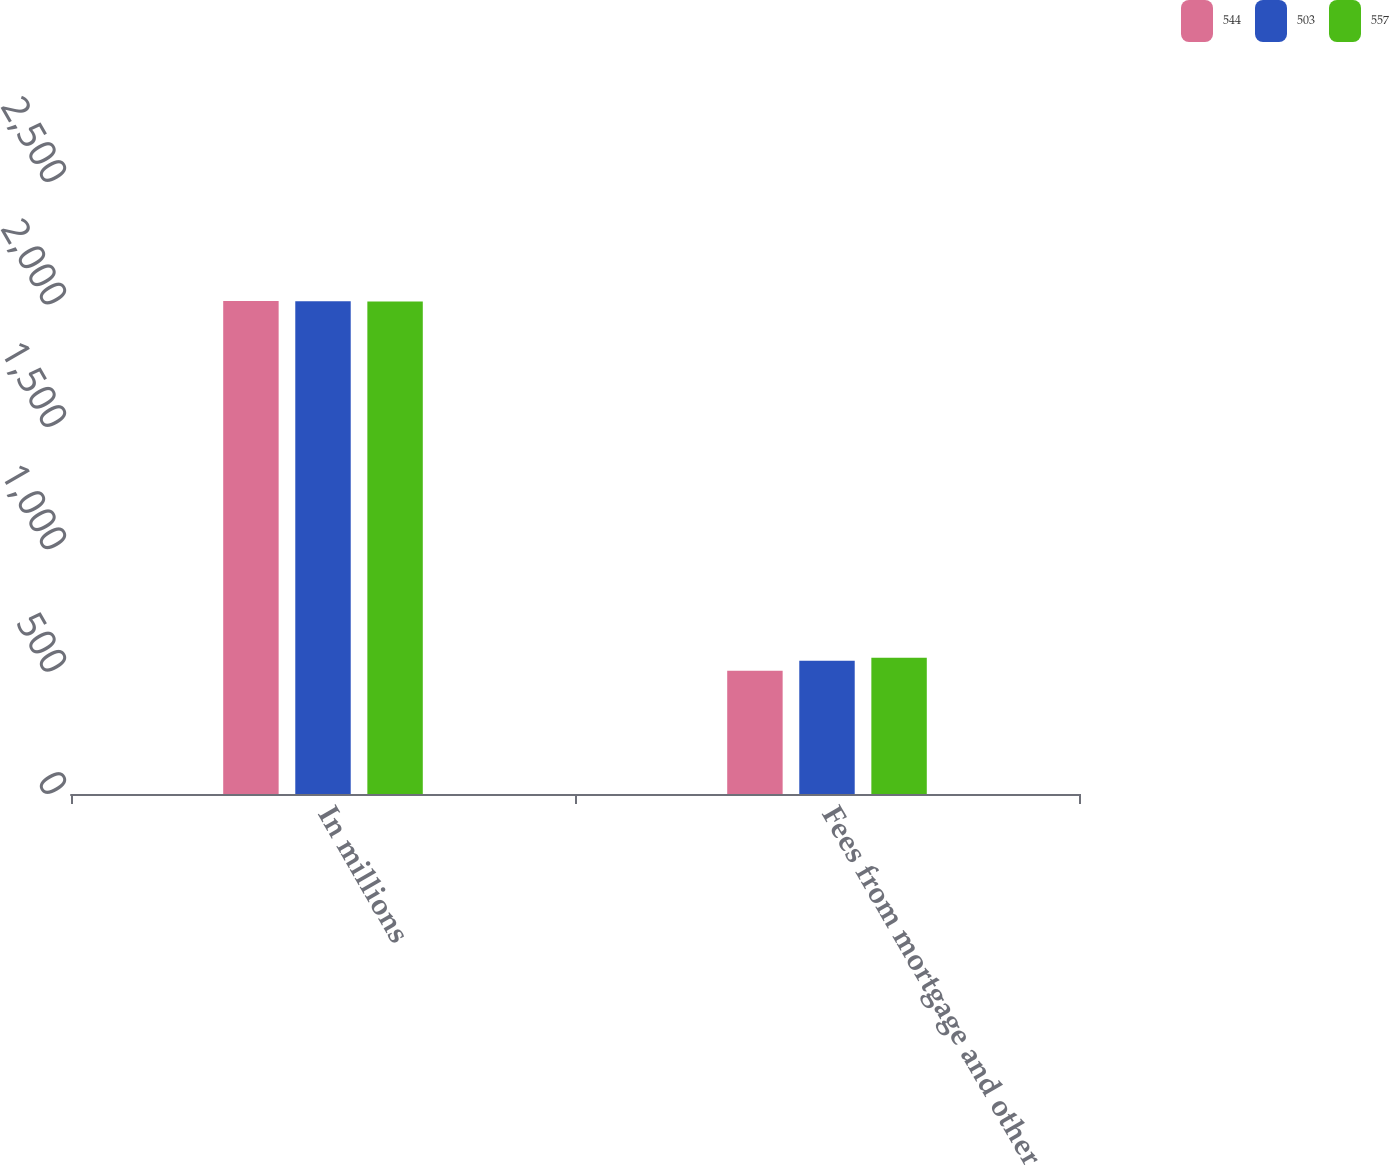Convert chart. <chart><loc_0><loc_0><loc_500><loc_500><stacked_bar_chart><ecel><fcel>In millions<fcel>Fees from mortgage and other<nl><fcel>544<fcel>2014<fcel>503<nl><fcel>503<fcel>2013<fcel>544<nl><fcel>557<fcel>2012<fcel>557<nl></chart> 